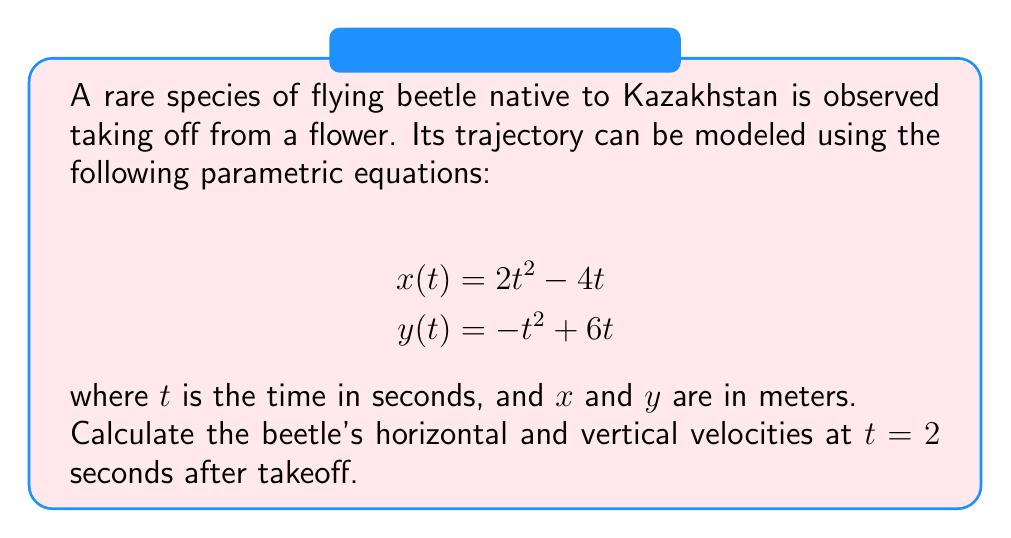Solve this math problem. To solve this problem, we need to find the velocities in both the x and y directions at t = 2 seconds. We can do this by taking the derivatives of the parametric equations with respect to time.

1. Find the horizontal velocity function $v_x(t)$:
   $$x(t) = 2t^2 - 4t$$
   $$v_x(t) = \frac{dx}{dt} = 4t - 4$$

2. Find the vertical velocity function $v_y(t)$:
   $$y(t) = -t^2 + 6t$$
   $$v_y(t) = \frac{dy}{dt} = -2t + 6$$

3. Calculate the horizontal velocity at t = 2 seconds:
   $$v_x(2) = 4(2) - 4 = 8 - 4 = 4$$

4. Calculate the vertical velocity at t = 2 seconds:
   $$v_y(2) = -2(2) + 6 = -4 + 6 = 2$$

Therefore, at t = 2 seconds:
- The horizontal velocity is 4 m/s
- The vertical velocity is 2 m/s
Answer: At t = 2 seconds, the beetle's horizontal velocity is 4 m/s and its vertical velocity is 2 m/s. 